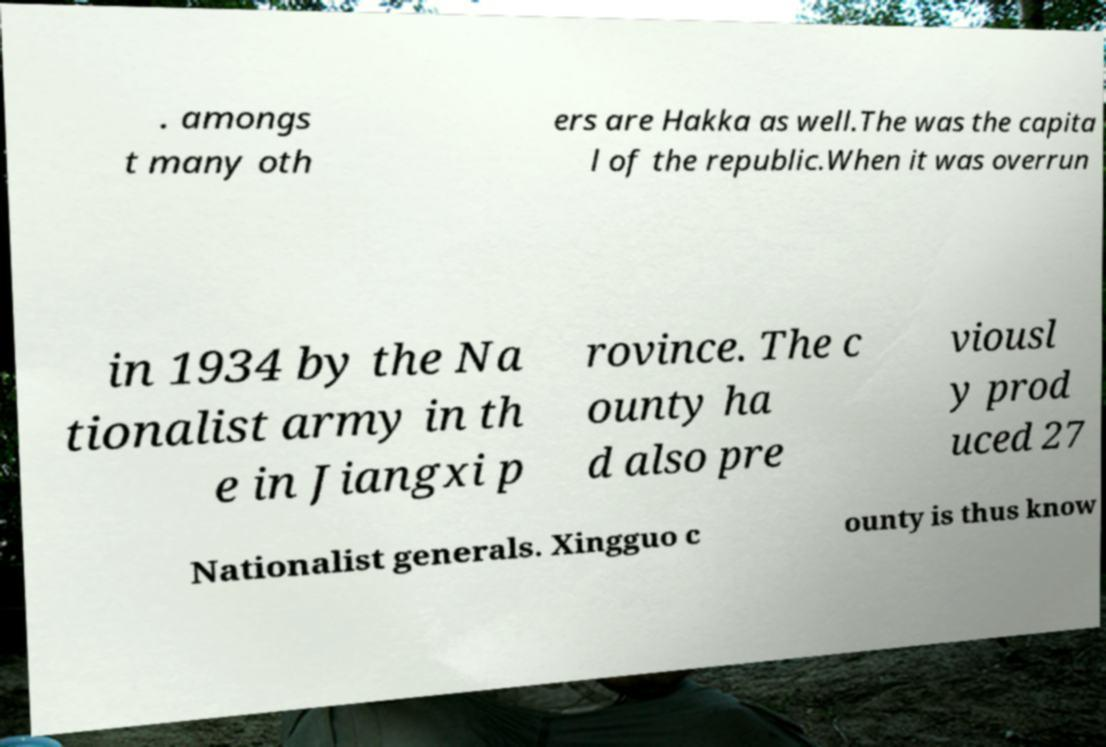Can you read and provide the text displayed in the image?This photo seems to have some interesting text. Can you extract and type it out for me? . amongs t many oth ers are Hakka as well.The was the capita l of the republic.When it was overrun in 1934 by the Na tionalist army in th e in Jiangxi p rovince. The c ounty ha d also pre viousl y prod uced 27 Nationalist generals. Xingguo c ounty is thus know 